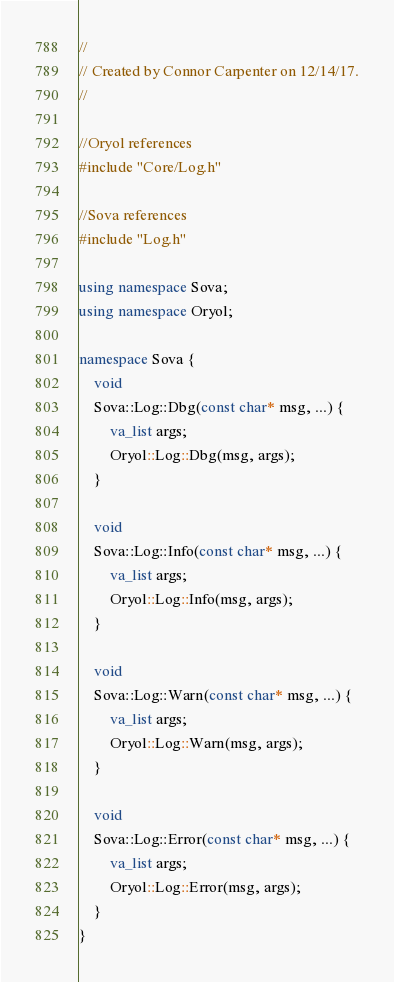<code> <loc_0><loc_0><loc_500><loc_500><_C++_>//
// Created by Connor Carpenter on 12/14/17.
//

//Oryol references
#include "Core/Log.h"

//Sova references
#include "Log.h"

using namespace Sova;
using namespace Oryol;

namespace Sova {
    void
    Sova::Log::Dbg(const char* msg, ...) {
        va_list args;
        Oryol::Log::Dbg(msg, args);
    }

    void
    Sova::Log::Info(const char* msg, ...) {
        va_list args;
        Oryol::Log::Info(msg, args);
    }

    void
    Sova::Log::Warn(const char* msg, ...) {
        va_list args;
        Oryol::Log::Warn(msg, args);
    }

    void
    Sova::Log::Error(const char* msg, ...) {
        va_list args;
        Oryol::Log::Error(msg, args);
    }
}

</code> 